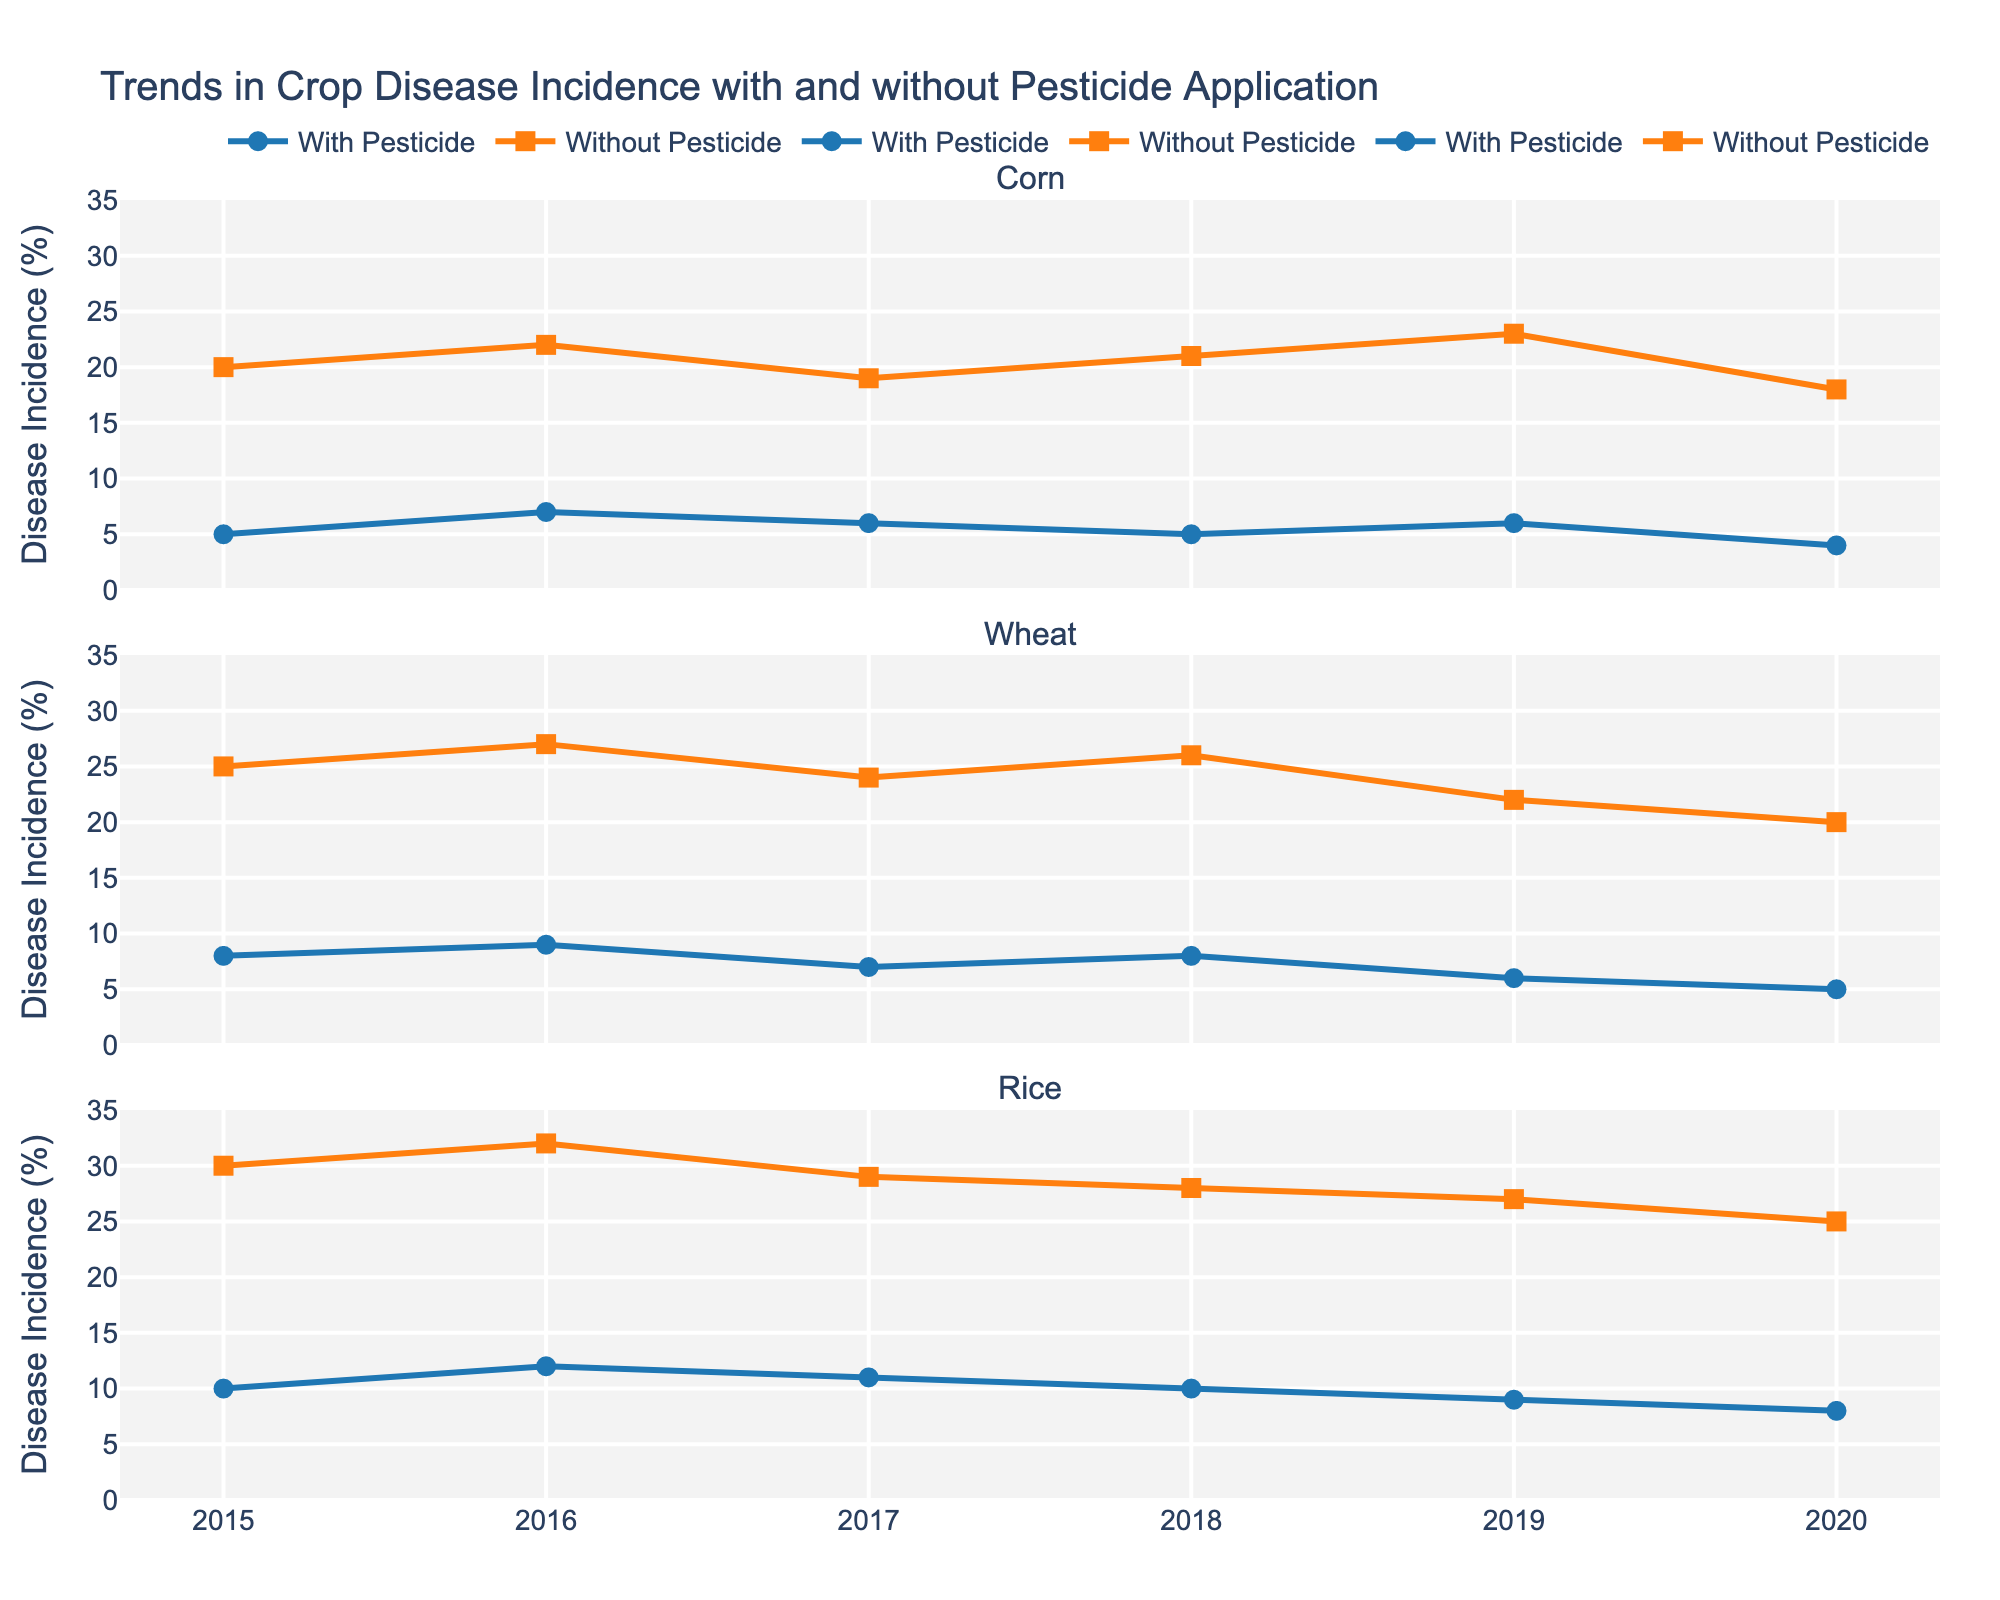What is the title of the figure? The title is typically located at the top of the figure. In this case, it mentions the main topic covered by the plots.
Answer: Trends in Crop Disease Incidence with and without Pesticide Application What are the two main colors used in the plots, and what do they represent? The colors in the plots differentiate between the two sets of data. The blue color represents one set while the orange color represents the other.
Answer: Blue for with pesticide, Orange for without How does the disease incidence for Corn in 2020 compare between pesticide and non-pesticide application? By looking at the data points for Corn in 2020, we can compare the values on the y-axis for both lines.
Answer: 4% with pesticide, 18% without pesticide What is the average disease incidence for Wheat with pesticide application over the years 2015 to 2020? To find the average, sum the disease incidence percentages for each year from 2015 to 2020 and divide by the number of years.
Answer: (8 + 9 + 7 + 8 + 6 + 5) / 6 = 7.17% In which year did Rice have the highest disease incidence without pesticide application? Look at the points on the Rice subplot for the orange line and identify the highest value.
Answer: 2016 In general, how does disease incidence with pesticide application in Corn compare to without pesticide application over the years? Observe the trend of the blue and orange lines in the Corn subplot. The blue line is consistently lower than the orange line, implying less disease incidence with pesticide use.
Answer: Lower disease incidence with pesticide What is the maximum difference in disease incidence for Rice between with and without pesticide application in any given year? Find the year with the largest gap between the blue and orange points for Rice and calculate the difference.
Answer: 2016, with a difference of 20% (32% without vs. 12% with) What trend can you observe in the disease incidence for Wheat from 2015 to 2020 without pesticide application? Study the orange line in the Wheat subplot and note how the values change from one year to the next.
Answer: The incidence decreases from 25% in 2015 to 20% in 2020 Which crop showed the smallest percentage decrease in disease incidence with pesticide application from 2015 to 2020? Calculate the percentage decrease for each crop between 2015 and 2020, then compare these values.
Answer: Wheat (8% to 5%, which is a 37.5% decrease) Summarize the general impact of pesticide application on disease incidence for all crops shown in the figure. Compare the trends and values for both with and without pesticide application across all crops. Generally, the blue lines are consistently lower than the orange lines, indicating less disease incidence with pesticide use.
Answer: Consistently reduces disease incidence 